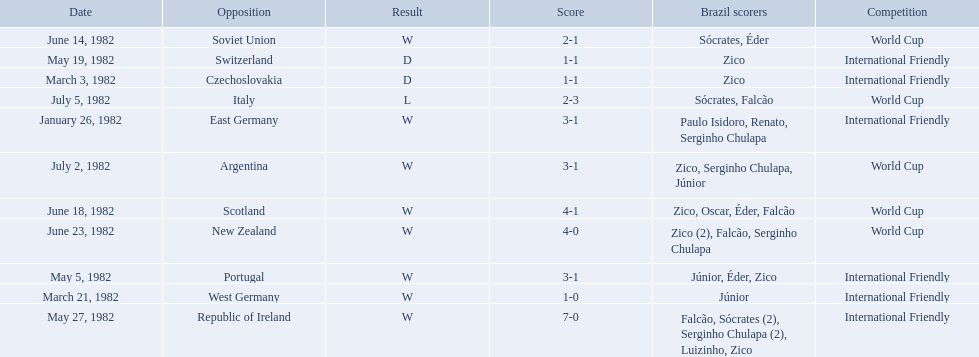What are the dates? January 26, 1982, March 3, 1982, March 21, 1982, May 5, 1982, May 19, 1982, May 27, 1982, June 14, 1982, June 18, 1982, June 23, 1982, July 2, 1982, July 5, 1982. And which date is listed first? January 26, 1982. 